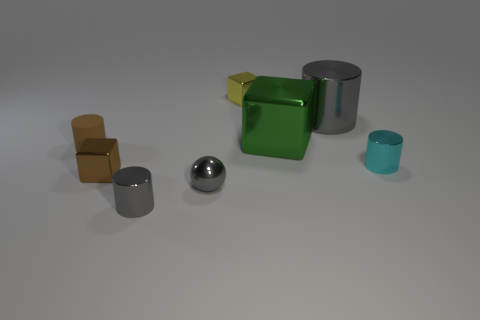How many blue rubber blocks have the same size as the green metal object?
Provide a succinct answer. 0. There is a small cylinder that is behind the brown shiny cube and to the right of the small brown shiny object; what color is it?
Your answer should be very brief. Cyan. Are there more things that are on the right side of the cyan cylinder than matte cylinders?
Offer a terse response. No. Is there a small blue matte sphere?
Offer a terse response. No. Is the tiny metal ball the same color as the tiny rubber cylinder?
Make the answer very short. No. How many tiny things are gray metallic things or shiny things?
Give a very brief answer. 5. Is there anything else that is the same color as the sphere?
Keep it short and to the point. Yes. There is a brown object that is the same material as the small yellow object; what shape is it?
Offer a very short reply. Cube. There is a brown metal block that is to the right of the small rubber cylinder; what size is it?
Provide a succinct answer. Small. There is a small yellow metal thing; what shape is it?
Provide a short and direct response. Cube. 